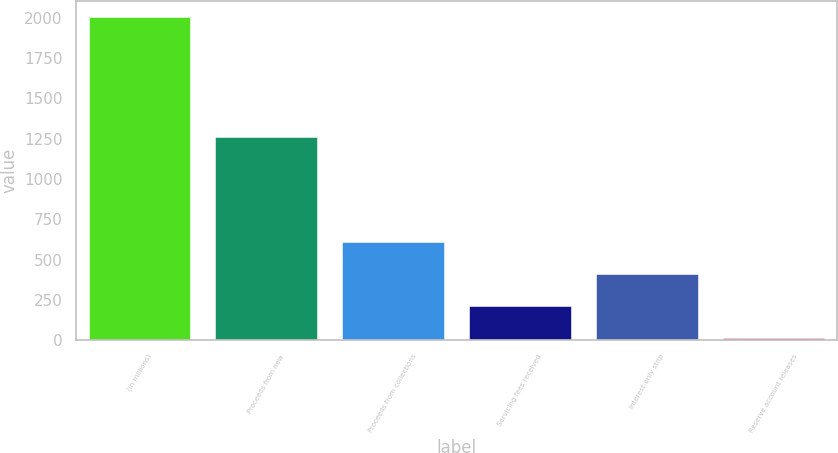Convert chart. <chart><loc_0><loc_0><loc_500><loc_500><bar_chart><fcel>(In millions)<fcel>Proceeds from new<fcel>Proceeds from collections<fcel>Servicing fees received<fcel>Interest-only strip<fcel>Reserve account releases<nl><fcel>2005<fcel>1260<fcel>611.37<fcel>213.19<fcel>412.28<fcel>14.1<nl></chart> 